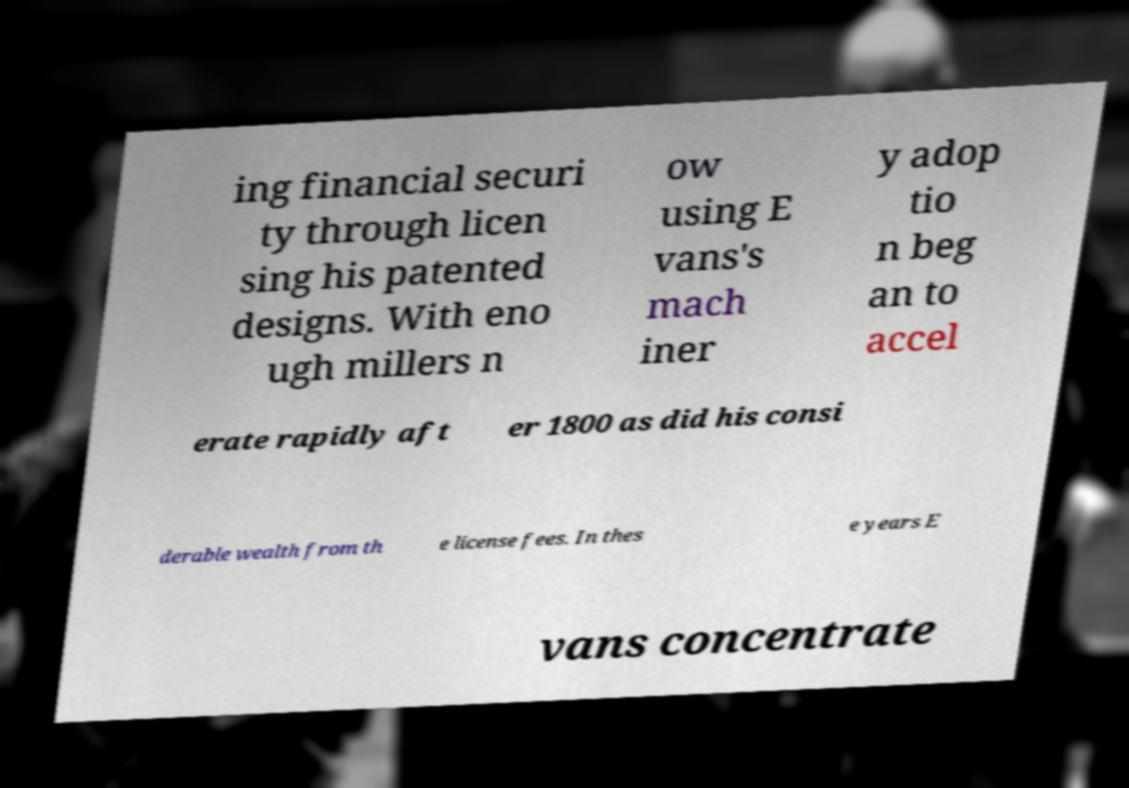Please read and relay the text visible in this image. What does it say? ing financial securi ty through licen sing his patented designs. With eno ugh millers n ow using E vans's mach iner y adop tio n beg an to accel erate rapidly aft er 1800 as did his consi derable wealth from th e license fees. In thes e years E vans concentrate 